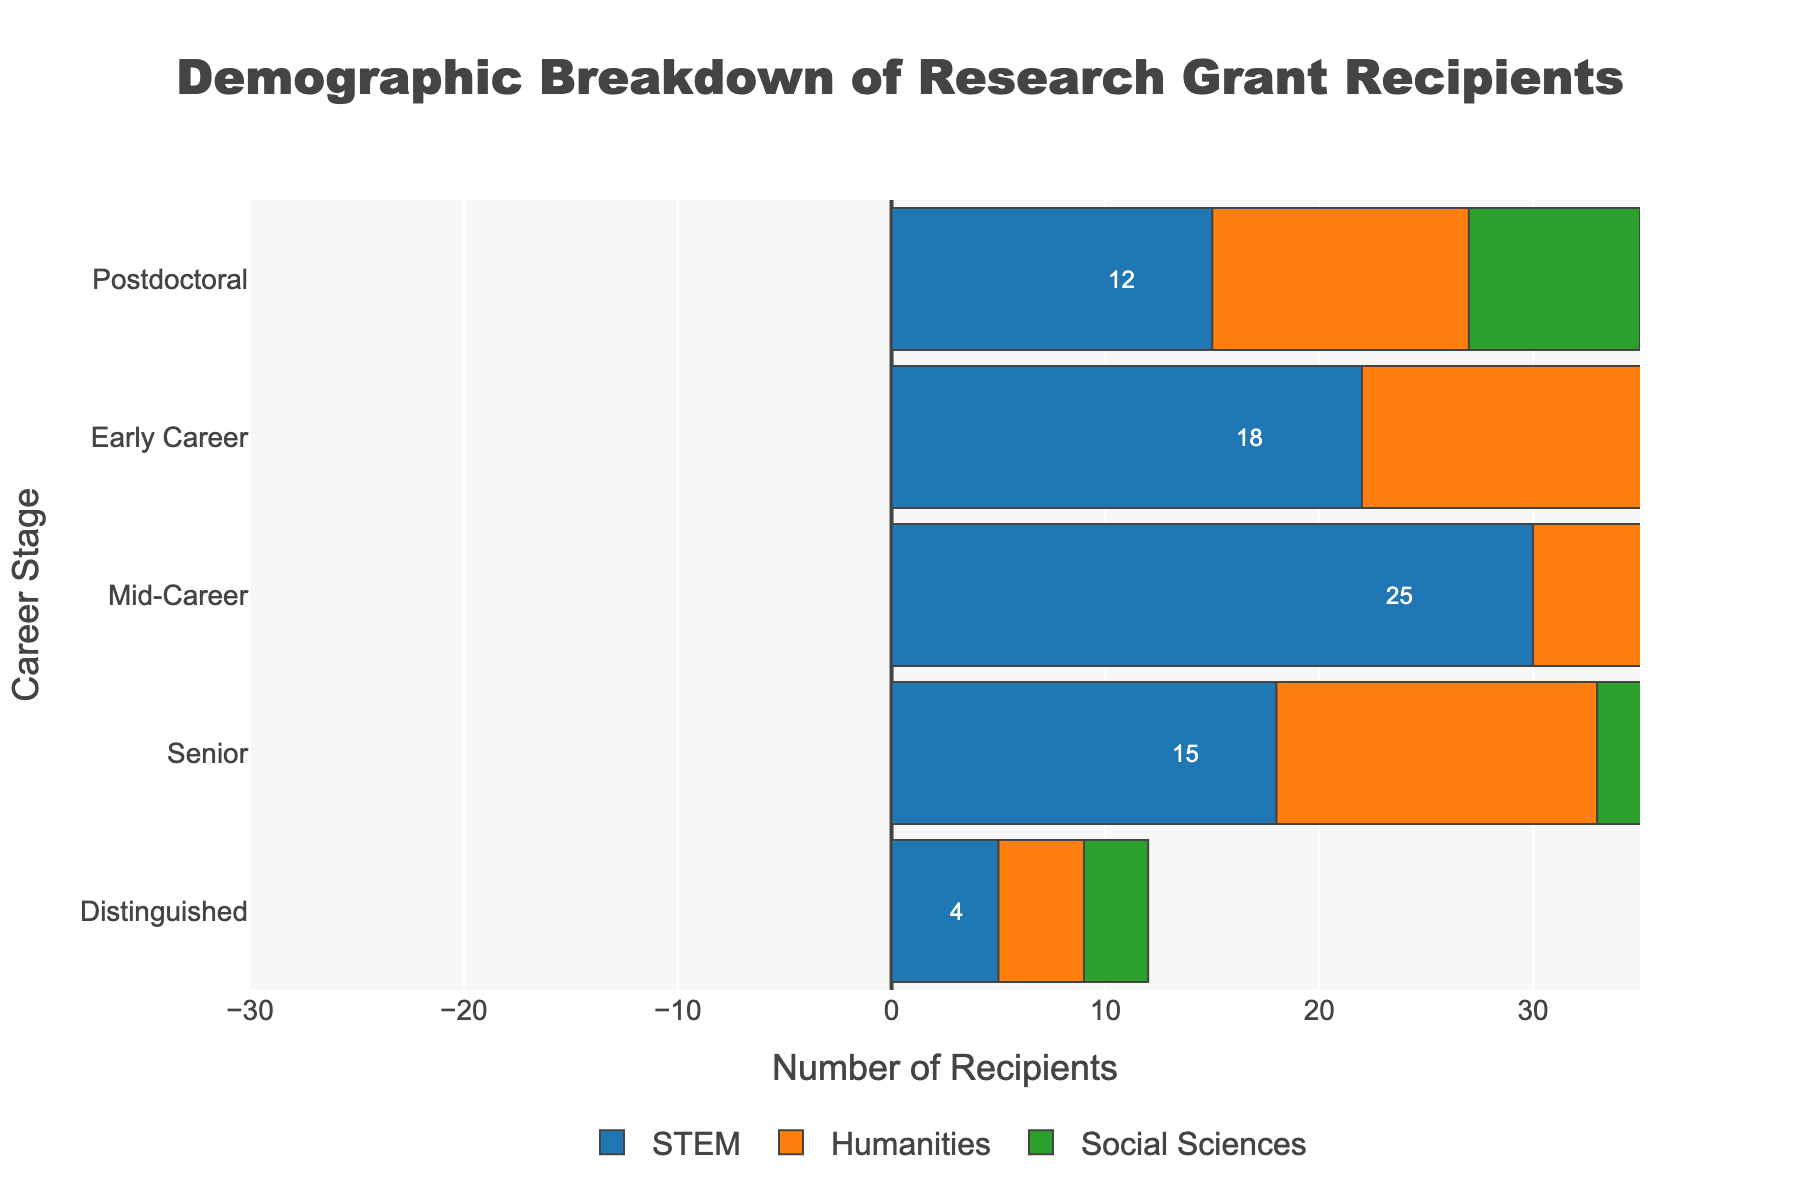What is the title of the figure? The title is usually located at the top of the figure. It reads "Demographic Breakdown of Research Grant Recipients".
Answer: Demographic Breakdown of Research Grant Recipients Which career stage has the largest number of STEM grant recipients? To find the answer, look at the bars for each career stage labeled 'STEM' and find the largest bar. The Mid-Career stage has the largest STEM bar with 30 recipients.
Answer: Mid-Career How many Humanities grant recipients are in the Early Career stage? The Early Career stage has a bar going to the left for Humanities. The value next to it shows -18, which means there are 18 Humanities grant recipients in this stage.
Answer: 18 What is the total number of Social Sciences grant recipients across all career stages? To find the total, sum up the Social Sciences values across all career stages: 8 + 14 + 20 + 12 + 3. The total is 57.
Answer: 57 Which academic discipline has the least recipients in the Distinguished career stage? Compare the bars for STEM, Humanities, and Social Sciences in the Distinguished stage. STEM has 5, Humanities has 4, and Social Sciences have 3 recipients. The least is Social Sciences with 3.
Answer: Social Sciences Do more Postdoctoral researchers receive grants in STEM or Humanities? Look at the bars for Postdoctoral researchers. STEM has a bar indicating 15 recipients, and Humanities has a bar indicating -12, which translates to 12 recipients. 15 is greater than 12.
Answer: STEM What is the difference in the number of Mid-Career grant recipients between STEM and Social Sciences? The Mid-Career stage has 30 recipients in STEM and 20 in Social Sciences. The difference is 30 - 20 = 10.
Answer: 10 Which career stage has the smallest overall variability in the number of grant recipients across the three disciplines? To find the smallest variability, compare the range of values for each stage. Distinguished has 5 (STEM), 4 (Humanities), and 3 (Social Sciences), giving a range of 2. Other stages have larger ranges.
Answer: Distinguished If Humanities recipients in Senior career stage increase by 6, what would be the new value? The current Humanities recipients in the Senior stage are -15. If it increases by 6, the new value is -15 + 6 = -9, which means there would be 9 recipients.
Answer: 9 Among Early Career researchers, do more receive grants in Social Sciences or Humanities? Look at the bars for Early Career researchers. Social Sciences has 14 recipients and Humanities has 18. 18 is greater than 14.
Answer: Humanities 